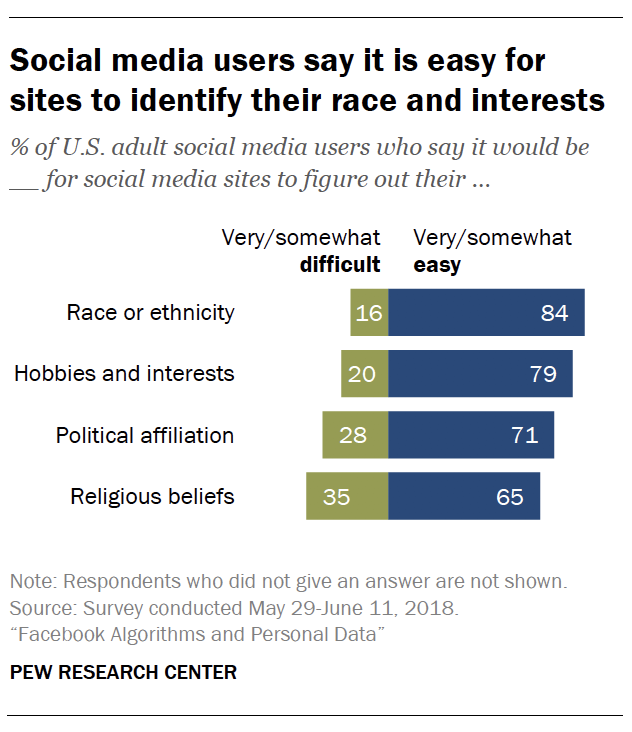List a handful of essential elements in this visual. The given text appears to be a series of numbers and a question. It is not clear what the question is asking exactly, but it seems to be asking if there is missing data among the given numbers. The numbers provided are 16, 20, and 35. The median of the green bars is 24. 